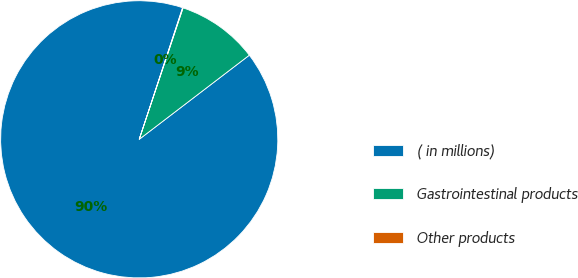<chart> <loc_0><loc_0><loc_500><loc_500><pie_chart><fcel>( in millions)<fcel>Gastrointestinal products<fcel>Other products<nl><fcel>90.45%<fcel>9.49%<fcel>0.06%<nl></chart> 